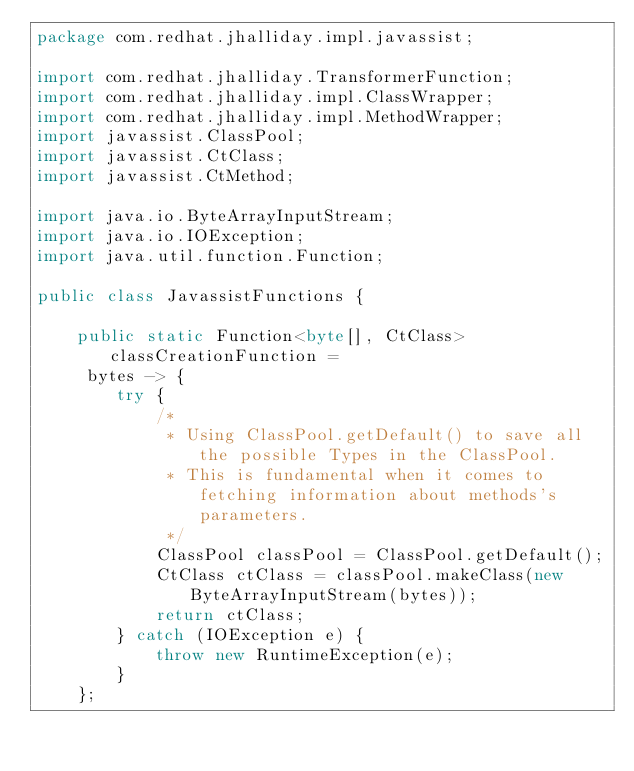Convert code to text. <code><loc_0><loc_0><loc_500><loc_500><_Java_>package com.redhat.jhalliday.impl.javassist;

import com.redhat.jhalliday.TransformerFunction;
import com.redhat.jhalliday.impl.ClassWrapper;
import com.redhat.jhalliday.impl.MethodWrapper;
import javassist.ClassPool;
import javassist.CtClass;
import javassist.CtMethod;

import java.io.ByteArrayInputStream;
import java.io.IOException;
import java.util.function.Function;

public class JavassistFunctions {

    public static Function<byte[], CtClass> classCreationFunction =
     bytes -> {
        try {
            /*
             * Using ClassPool.getDefault() to save all the possible Types in the ClassPool.
             * This is fundamental when it comes to fetching information about methods's parameters.
             */
            ClassPool classPool = ClassPool.getDefault();
            CtClass ctClass = classPool.makeClass(new ByteArrayInputStream(bytes));
            return ctClass;
        } catch (IOException e) {
            throw new RuntimeException(e);
        }
    };
</code> 